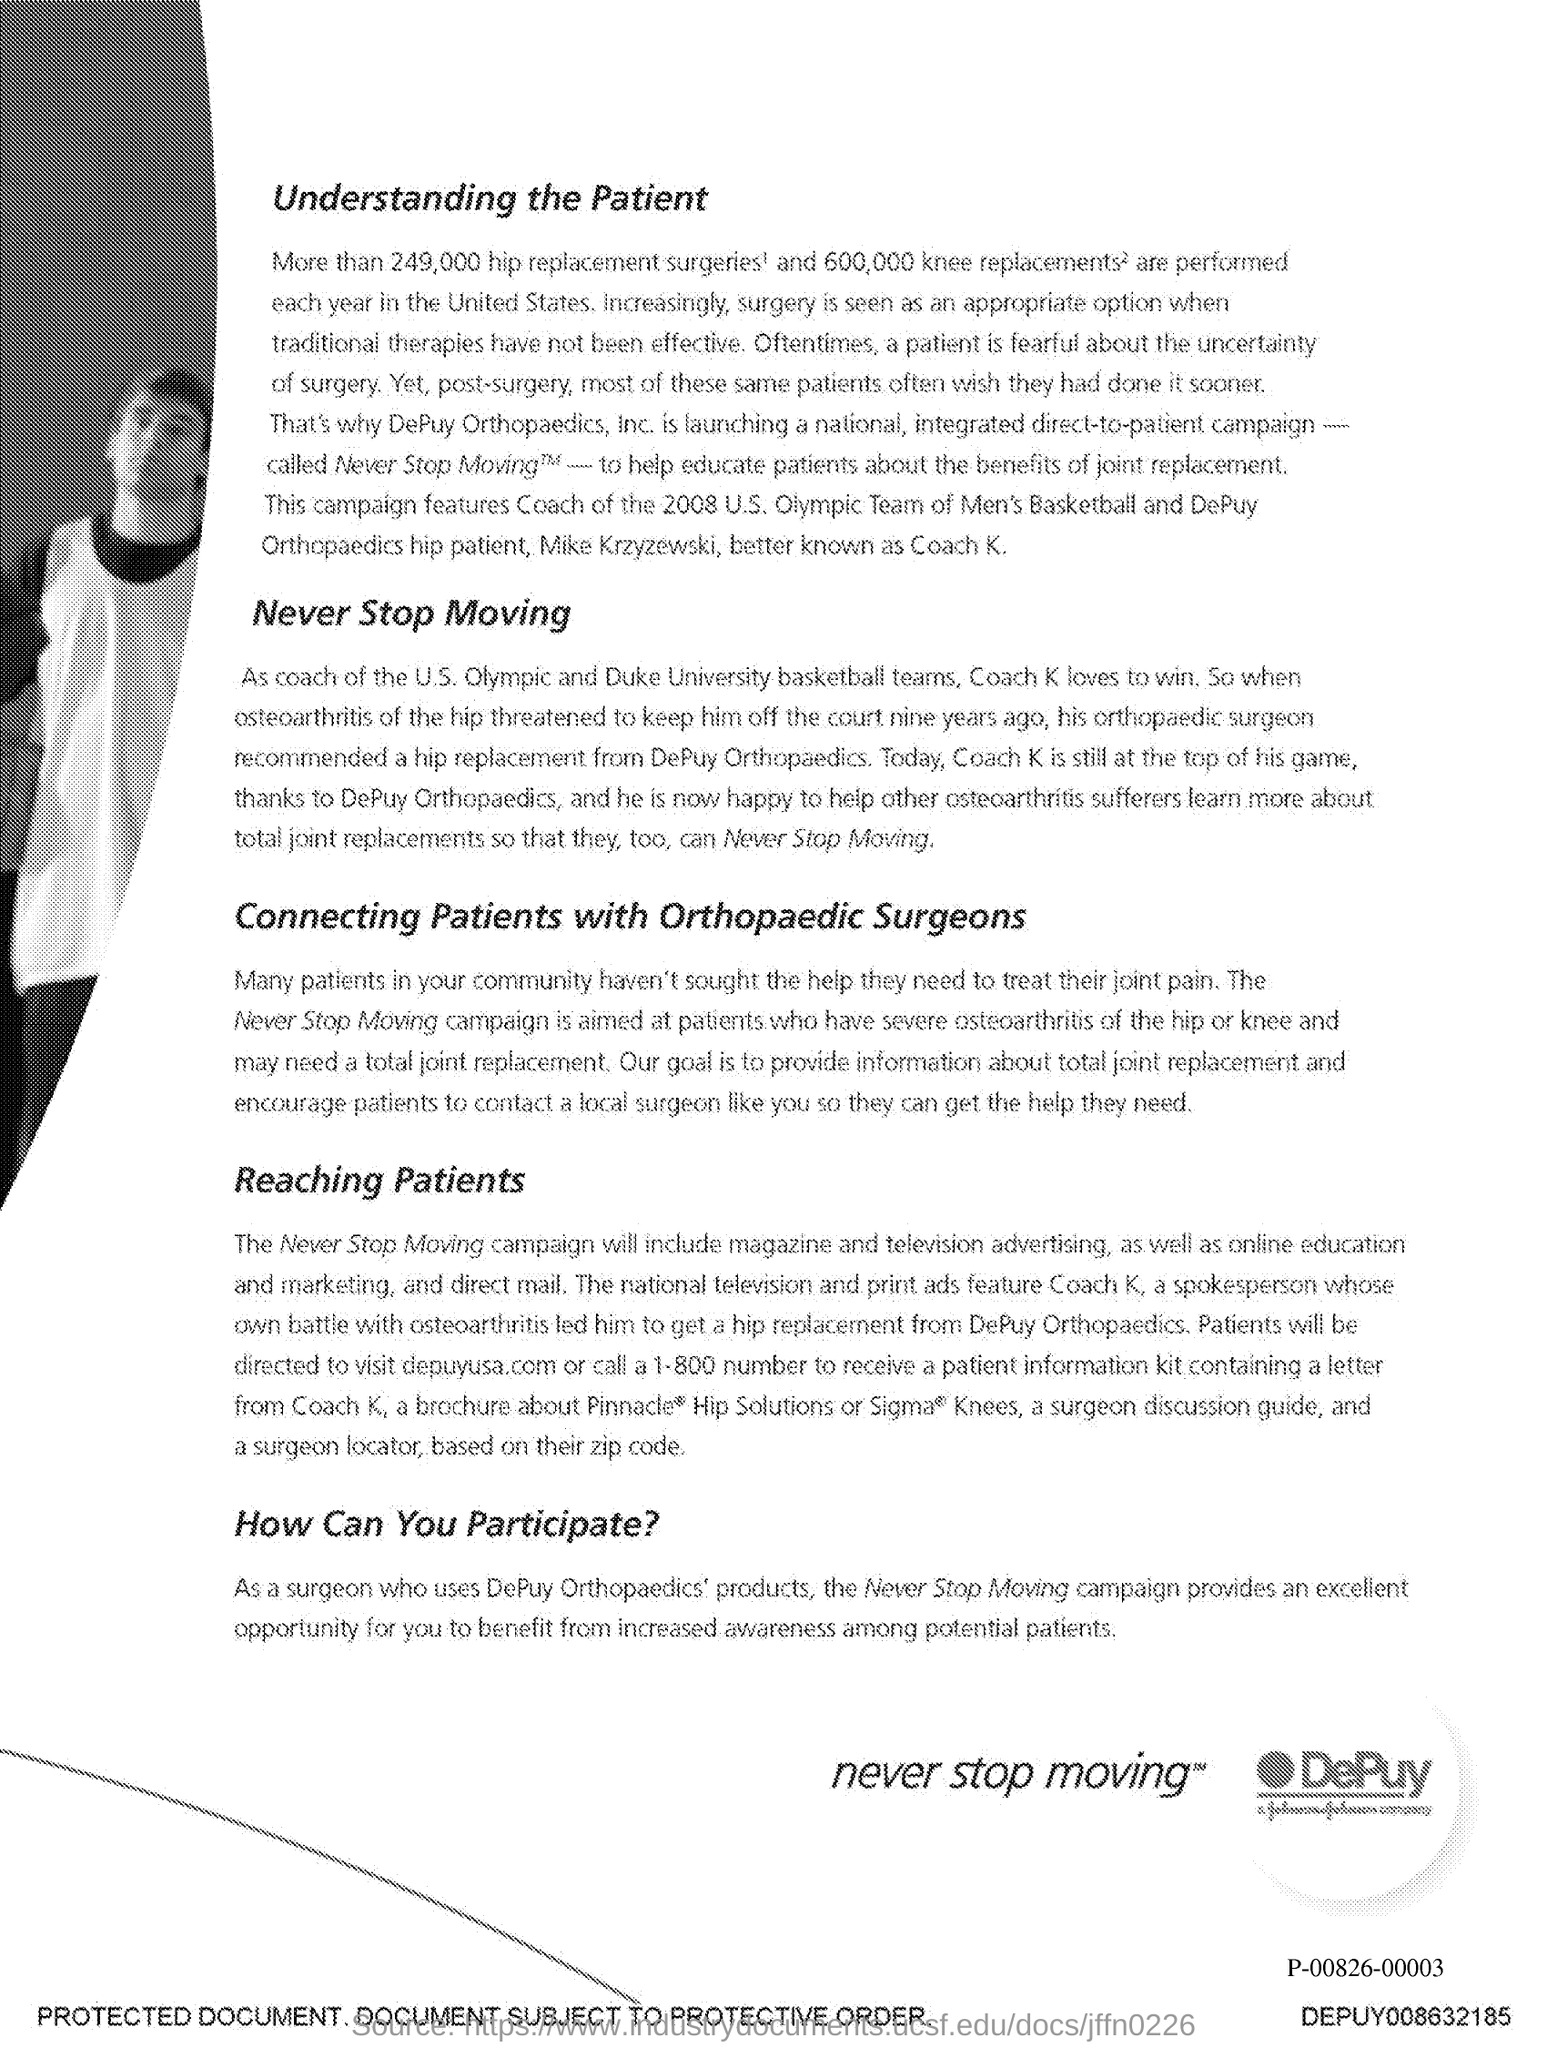Highlight a few significant elements in this photo. The document's first title is 'Understanding the Patient'. The second title in this document is 'Never stop moving.' 